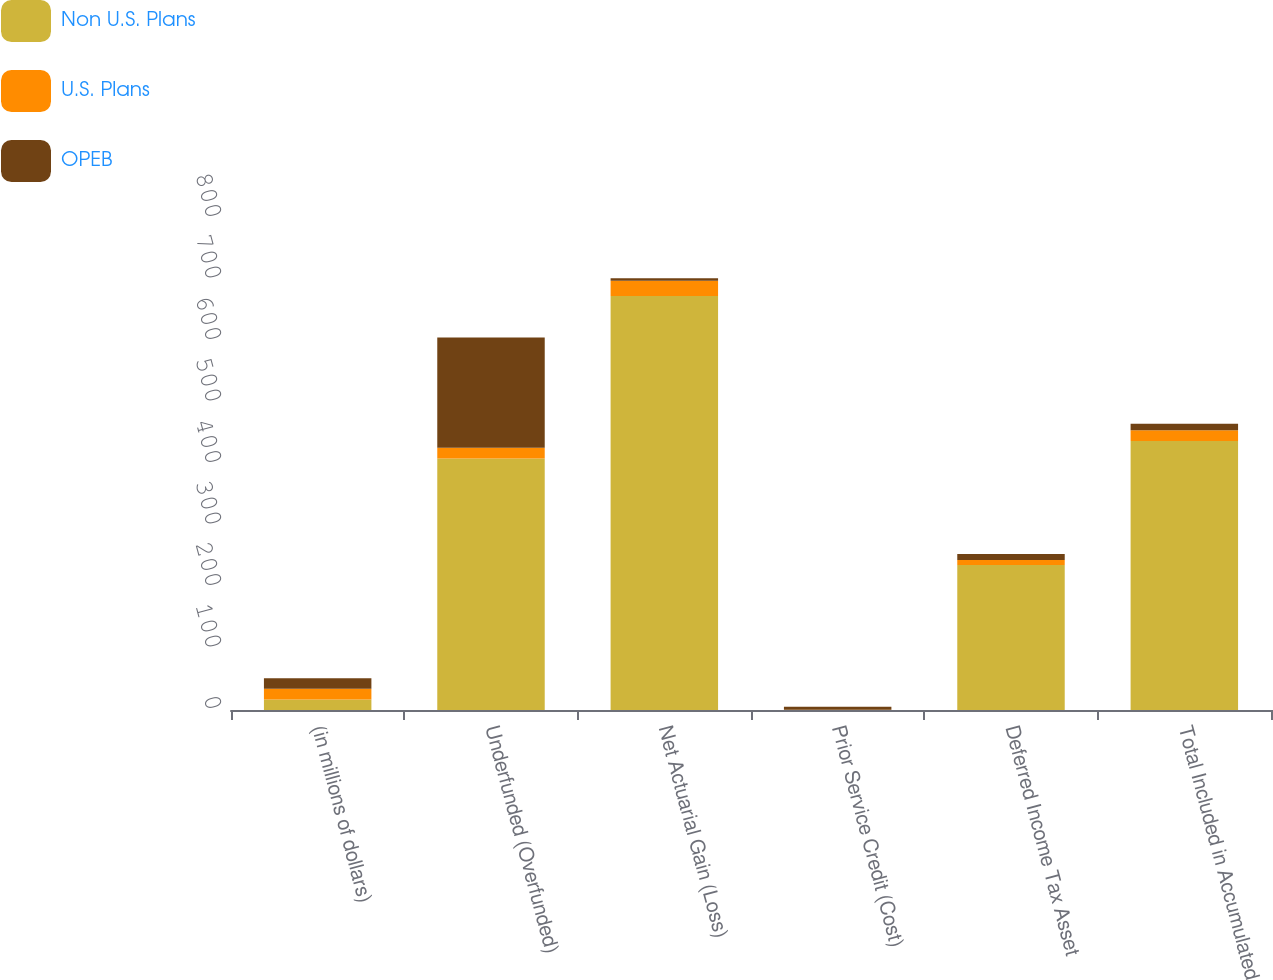<chart> <loc_0><loc_0><loc_500><loc_500><stacked_bar_chart><ecel><fcel>(in millions of dollars)<fcel>Underfunded (Overfunded)<fcel>Net Actuarial Gain (Loss)<fcel>Prior Service Credit (Cost)<fcel>Deferred Income Tax Asset<fcel>Total Included in Accumulated<nl><fcel>Non U.S. Plans<fcel>17.2<fcel>409<fcel>673.1<fcel>0.2<fcel>235.7<fcel>437.6<nl><fcel>U.S. Plans<fcel>17.2<fcel>17.6<fcel>25<fcel>0.2<fcel>8<fcel>17.2<nl><fcel>OPEB<fcel>17.2<fcel>179.2<fcel>4.1<fcel>4.9<fcel>9.9<fcel>10.7<nl></chart> 